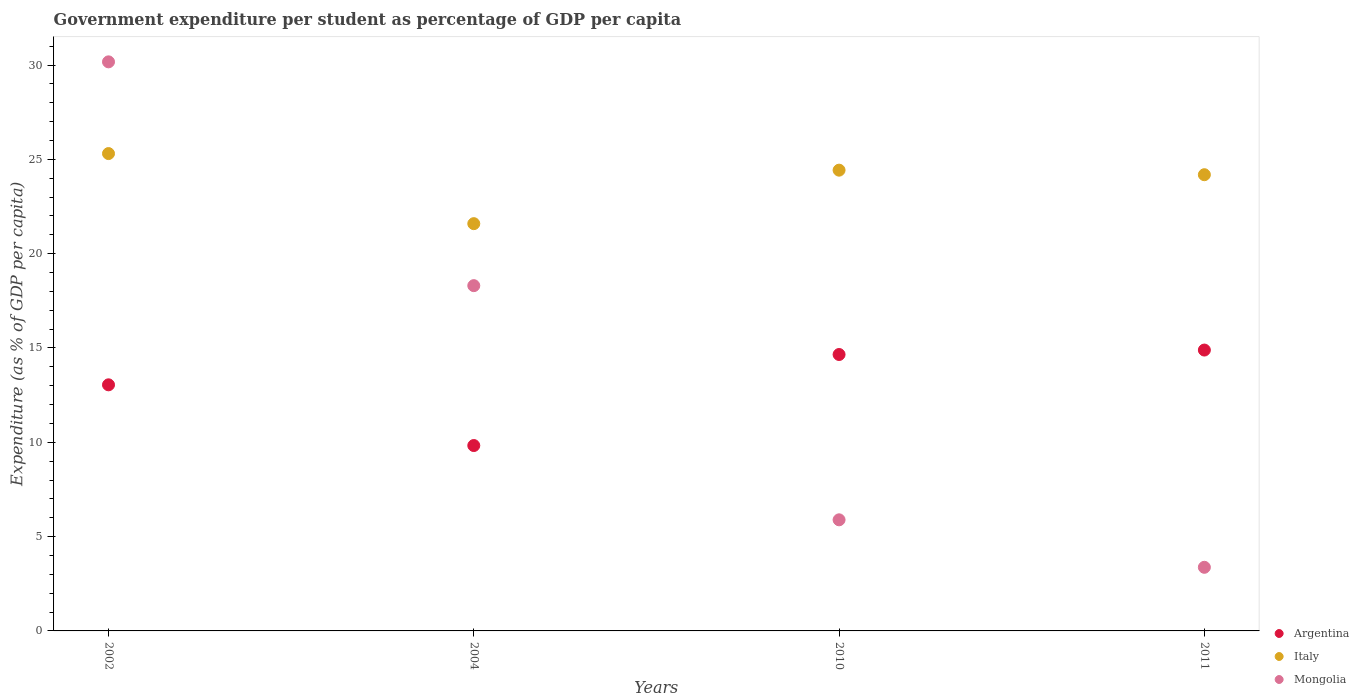How many different coloured dotlines are there?
Your answer should be compact. 3. Is the number of dotlines equal to the number of legend labels?
Make the answer very short. Yes. What is the percentage of expenditure per student in Mongolia in 2002?
Make the answer very short. 30.17. Across all years, what is the maximum percentage of expenditure per student in Argentina?
Offer a terse response. 14.89. Across all years, what is the minimum percentage of expenditure per student in Argentina?
Your answer should be compact. 9.83. In which year was the percentage of expenditure per student in Argentina maximum?
Provide a short and direct response. 2011. In which year was the percentage of expenditure per student in Argentina minimum?
Provide a short and direct response. 2004. What is the total percentage of expenditure per student in Italy in the graph?
Offer a very short reply. 95.51. What is the difference between the percentage of expenditure per student in Italy in 2002 and that in 2004?
Keep it short and to the point. 3.72. What is the difference between the percentage of expenditure per student in Italy in 2004 and the percentage of expenditure per student in Mongolia in 2010?
Your response must be concise. 15.7. What is the average percentage of expenditure per student in Mongolia per year?
Give a very brief answer. 14.43. In the year 2002, what is the difference between the percentage of expenditure per student in Italy and percentage of expenditure per student in Argentina?
Provide a succinct answer. 12.26. What is the ratio of the percentage of expenditure per student in Italy in 2004 to that in 2010?
Give a very brief answer. 0.88. Is the percentage of expenditure per student in Italy in 2010 less than that in 2011?
Your response must be concise. No. What is the difference between the highest and the second highest percentage of expenditure per student in Argentina?
Make the answer very short. 0.24. What is the difference between the highest and the lowest percentage of expenditure per student in Mongolia?
Ensure brevity in your answer.  26.8. In how many years, is the percentage of expenditure per student in Argentina greater than the average percentage of expenditure per student in Argentina taken over all years?
Make the answer very short. 2. Is the sum of the percentage of expenditure per student in Argentina in 2004 and 2011 greater than the maximum percentage of expenditure per student in Mongolia across all years?
Keep it short and to the point. No. Is it the case that in every year, the sum of the percentage of expenditure per student in Argentina and percentage of expenditure per student in Italy  is greater than the percentage of expenditure per student in Mongolia?
Provide a succinct answer. Yes. Is the percentage of expenditure per student in Mongolia strictly greater than the percentage of expenditure per student in Italy over the years?
Make the answer very short. No. Is the percentage of expenditure per student in Mongolia strictly less than the percentage of expenditure per student in Argentina over the years?
Ensure brevity in your answer.  No. How many dotlines are there?
Keep it short and to the point. 3. Does the graph contain any zero values?
Offer a terse response. No. Does the graph contain grids?
Make the answer very short. No. Where does the legend appear in the graph?
Give a very brief answer. Bottom right. How are the legend labels stacked?
Your answer should be compact. Vertical. What is the title of the graph?
Ensure brevity in your answer.  Government expenditure per student as percentage of GDP per capita. What is the label or title of the X-axis?
Ensure brevity in your answer.  Years. What is the label or title of the Y-axis?
Your answer should be very brief. Expenditure (as % of GDP per capita). What is the Expenditure (as % of GDP per capita) in Argentina in 2002?
Your response must be concise. 13.05. What is the Expenditure (as % of GDP per capita) in Italy in 2002?
Offer a very short reply. 25.31. What is the Expenditure (as % of GDP per capita) in Mongolia in 2002?
Your answer should be very brief. 30.17. What is the Expenditure (as % of GDP per capita) in Argentina in 2004?
Ensure brevity in your answer.  9.83. What is the Expenditure (as % of GDP per capita) in Italy in 2004?
Provide a succinct answer. 21.59. What is the Expenditure (as % of GDP per capita) of Mongolia in 2004?
Keep it short and to the point. 18.3. What is the Expenditure (as % of GDP per capita) of Argentina in 2010?
Offer a very short reply. 14.65. What is the Expenditure (as % of GDP per capita) in Italy in 2010?
Offer a very short reply. 24.43. What is the Expenditure (as % of GDP per capita) in Mongolia in 2010?
Provide a succinct answer. 5.89. What is the Expenditure (as % of GDP per capita) in Argentina in 2011?
Offer a very short reply. 14.89. What is the Expenditure (as % of GDP per capita) of Italy in 2011?
Give a very brief answer. 24.19. What is the Expenditure (as % of GDP per capita) in Mongolia in 2011?
Your answer should be compact. 3.37. Across all years, what is the maximum Expenditure (as % of GDP per capita) in Argentina?
Your answer should be compact. 14.89. Across all years, what is the maximum Expenditure (as % of GDP per capita) in Italy?
Provide a succinct answer. 25.31. Across all years, what is the maximum Expenditure (as % of GDP per capita) in Mongolia?
Ensure brevity in your answer.  30.17. Across all years, what is the minimum Expenditure (as % of GDP per capita) of Argentina?
Your answer should be very brief. 9.83. Across all years, what is the minimum Expenditure (as % of GDP per capita) of Italy?
Your response must be concise. 21.59. Across all years, what is the minimum Expenditure (as % of GDP per capita) of Mongolia?
Your answer should be very brief. 3.37. What is the total Expenditure (as % of GDP per capita) in Argentina in the graph?
Make the answer very short. 52.42. What is the total Expenditure (as % of GDP per capita) of Italy in the graph?
Your response must be concise. 95.51. What is the total Expenditure (as % of GDP per capita) of Mongolia in the graph?
Your answer should be very brief. 57.74. What is the difference between the Expenditure (as % of GDP per capita) of Argentina in 2002 and that in 2004?
Give a very brief answer. 3.22. What is the difference between the Expenditure (as % of GDP per capita) of Italy in 2002 and that in 2004?
Your response must be concise. 3.72. What is the difference between the Expenditure (as % of GDP per capita) of Mongolia in 2002 and that in 2004?
Your response must be concise. 11.86. What is the difference between the Expenditure (as % of GDP per capita) in Argentina in 2002 and that in 2010?
Keep it short and to the point. -1.61. What is the difference between the Expenditure (as % of GDP per capita) of Italy in 2002 and that in 2010?
Ensure brevity in your answer.  0.88. What is the difference between the Expenditure (as % of GDP per capita) in Mongolia in 2002 and that in 2010?
Ensure brevity in your answer.  24.28. What is the difference between the Expenditure (as % of GDP per capita) of Argentina in 2002 and that in 2011?
Ensure brevity in your answer.  -1.84. What is the difference between the Expenditure (as % of GDP per capita) of Italy in 2002 and that in 2011?
Your answer should be compact. 1.12. What is the difference between the Expenditure (as % of GDP per capita) in Mongolia in 2002 and that in 2011?
Offer a terse response. 26.8. What is the difference between the Expenditure (as % of GDP per capita) of Argentina in 2004 and that in 2010?
Provide a succinct answer. -4.83. What is the difference between the Expenditure (as % of GDP per capita) in Italy in 2004 and that in 2010?
Your answer should be very brief. -2.84. What is the difference between the Expenditure (as % of GDP per capita) in Mongolia in 2004 and that in 2010?
Keep it short and to the point. 12.41. What is the difference between the Expenditure (as % of GDP per capita) in Argentina in 2004 and that in 2011?
Your response must be concise. -5.06. What is the difference between the Expenditure (as % of GDP per capita) of Italy in 2004 and that in 2011?
Offer a terse response. -2.59. What is the difference between the Expenditure (as % of GDP per capita) in Mongolia in 2004 and that in 2011?
Make the answer very short. 14.93. What is the difference between the Expenditure (as % of GDP per capita) of Argentina in 2010 and that in 2011?
Provide a short and direct response. -0.24. What is the difference between the Expenditure (as % of GDP per capita) in Italy in 2010 and that in 2011?
Ensure brevity in your answer.  0.24. What is the difference between the Expenditure (as % of GDP per capita) of Mongolia in 2010 and that in 2011?
Provide a succinct answer. 2.52. What is the difference between the Expenditure (as % of GDP per capita) of Argentina in 2002 and the Expenditure (as % of GDP per capita) of Italy in 2004?
Ensure brevity in your answer.  -8.54. What is the difference between the Expenditure (as % of GDP per capita) in Argentina in 2002 and the Expenditure (as % of GDP per capita) in Mongolia in 2004?
Keep it short and to the point. -5.26. What is the difference between the Expenditure (as % of GDP per capita) in Italy in 2002 and the Expenditure (as % of GDP per capita) in Mongolia in 2004?
Give a very brief answer. 7. What is the difference between the Expenditure (as % of GDP per capita) in Argentina in 2002 and the Expenditure (as % of GDP per capita) in Italy in 2010?
Keep it short and to the point. -11.38. What is the difference between the Expenditure (as % of GDP per capita) in Argentina in 2002 and the Expenditure (as % of GDP per capita) in Mongolia in 2010?
Keep it short and to the point. 7.16. What is the difference between the Expenditure (as % of GDP per capita) in Italy in 2002 and the Expenditure (as % of GDP per capita) in Mongolia in 2010?
Your response must be concise. 19.42. What is the difference between the Expenditure (as % of GDP per capita) of Argentina in 2002 and the Expenditure (as % of GDP per capita) of Italy in 2011?
Your response must be concise. -11.14. What is the difference between the Expenditure (as % of GDP per capita) of Argentina in 2002 and the Expenditure (as % of GDP per capita) of Mongolia in 2011?
Your response must be concise. 9.67. What is the difference between the Expenditure (as % of GDP per capita) of Italy in 2002 and the Expenditure (as % of GDP per capita) of Mongolia in 2011?
Provide a succinct answer. 21.93. What is the difference between the Expenditure (as % of GDP per capita) of Argentina in 2004 and the Expenditure (as % of GDP per capita) of Italy in 2010?
Your answer should be compact. -14.6. What is the difference between the Expenditure (as % of GDP per capita) of Argentina in 2004 and the Expenditure (as % of GDP per capita) of Mongolia in 2010?
Provide a short and direct response. 3.94. What is the difference between the Expenditure (as % of GDP per capita) in Italy in 2004 and the Expenditure (as % of GDP per capita) in Mongolia in 2010?
Make the answer very short. 15.7. What is the difference between the Expenditure (as % of GDP per capita) in Argentina in 2004 and the Expenditure (as % of GDP per capita) in Italy in 2011?
Ensure brevity in your answer.  -14.36. What is the difference between the Expenditure (as % of GDP per capita) of Argentina in 2004 and the Expenditure (as % of GDP per capita) of Mongolia in 2011?
Keep it short and to the point. 6.46. What is the difference between the Expenditure (as % of GDP per capita) of Italy in 2004 and the Expenditure (as % of GDP per capita) of Mongolia in 2011?
Your answer should be compact. 18.22. What is the difference between the Expenditure (as % of GDP per capita) in Argentina in 2010 and the Expenditure (as % of GDP per capita) in Italy in 2011?
Your response must be concise. -9.53. What is the difference between the Expenditure (as % of GDP per capita) of Argentina in 2010 and the Expenditure (as % of GDP per capita) of Mongolia in 2011?
Ensure brevity in your answer.  11.28. What is the difference between the Expenditure (as % of GDP per capita) in Italy in 2010 and the Expenditure (as % of GDP per capita) in Mongolia in 2011?
Offer a very short reply. 21.05. What is the average Expenditure (as % of GDP per capita) of Argentina per year?
Your answer should be very brief. 13.1. What is the average Expenditure (as % of GDP per capita) in Italy per year?
Keep it short and to the point. 23.88. What is the average Expenditure (as % of GDP per capita) in Mongolia per year?
Offer a terse response. 14.43. In the year 2002, what is the difference between the Expenditure (as % of GDP per capita) of Argentina and Expenditure (as % of GDP per capita) of Italy?
Your response must be concise. -12.26. In the year 2002, what is the difference between the Expenditure (as % of GDP per capita) in Argentina and Expenditure (as % of GDP per capita) in Mongolia?
Ensure brevity in your answer.  -17.12. In the year 2002, what is the difference between the Expenditure (as % of GDP per capita) in Italy and Expenditure (as % of GDP per capita) in Mongolia?
Offer a very short reply. -4.86. In the year 2004, what is the difference between the Expenditure (as % of GDP per capita) in Argentina and Expenditure (as % of GDP per capita) in Italy?
Keep it short and to the point. -11.76. In the year 2004, what is the difference between the Expenditure (as % of GDP per capita) of Argentina and Expenditure (as % of GDP per capita) of Mongolia?
Ensure brevity in your answer.  -8.48. In the year 2004, what is the difference between the Expenditure (as % of GDP per capita) in Italy and Expenditure (as % of GDP per capita) in Mongolia?
Make the answer very short. 3.29. In the year 2010, what is the difference between the Expenditure (as % of GDP per capita) in Argentina and Expenditure (as % of GDP per capita) in Italy?
Your answer should be very brief. -9.77. In the year 2010, what is the difference between the Expenditure (as % of GDP per capita) in Argentina and Expenditure (as % of GDP per capita) in Mongolia?
Make the answer very short. 8.76. In the year 2010, what is the difference between the Expenditure (as % of GDP per capita) in Italy and Expenditure (as % of GDP per capita) in Mongolia?
Make the answer very short. 18.54. In the year 2011, what is the difference between the Expenditure (as % of GDP per capita) of Argentina and Expenditure (as % of GDP per capita) of Italy?
Provide a succinct answer. -9.3. In the year 2011, what is the difference between the Expenditure (as % of GDP per capita) of Argentina and Expenditure (as % of GDP per capita) of Mongolia?
Your answer should be very brief. 11.52. In the year 2011, what is the difference between the Expenditure (as % of GDP per capita) of Italy and Expenditure (as % of GDP per capita) of Mongolia?
Provide a short and direct response. 20.81. What is the ratio of the Expenditure (as % of GDP per capita) of Argentina in 2002 to that in 2004?
Offer a very short reply. 1.33. What is the ratio of the Expenditure (as % of GDP per capita) in Italy in 2002 to that in 2004?
Ensure brevity in your answer.  1.17. What is the ratio of the Expenditure (as % of GDP per capita) of Mongolia in 2002 to that in 2004?
Keep it short and to the point. 1.65. What is the ratio of the Expenditure (as % of GDP per capita) in Argentina in 2002 to that in 2010?
Keep it short and to the point. 0.89. What is the ratio of the Expenditure (as % of GDP per capita) of Italy in 2002 to that in 2010?
Provide a succinct answer. 1.04. What is the ratio of the Expenditure (as % of GDP per capita) in Mongolia in 2002 to that in 2010?
Give a very brief answer. 5.12. What is the ratio of the Expenditure (as % of GDP per capita) of Argentina in 2002 to that in 2011?
Give a very brief answer. 0.88. What is the ratio of the Expenditure (as % of GDP per capita) in Italy in 2002 to that in 2011?
Give a very brief answer. 1.05. What is the ratio of the Expenditure (as % of GDP per capita) of Mongolia in 2002 to that in 2011?
Your answer should be compact. 8.94. What is the ratio of the Expenditure (as % of GDP per capita) of Argentina in 2004 to that in 2010?
Make the answer very short. 0.67. What is the ratio of the Expenditure (as % of GDP per capita) in Italy in 2004 to that in 2010?
Your response must be concise. 0.88. What is the ratio of the Expenditure (as % of GDP per capita) of Mongolia in 2004 to that in 2010?
Your answer should be very brief. 3.11. What is the ratio of the Expenditure (as % of GDP per capita) in Argentina in 2004 to that in 2011?
Give a very brief answer. 0.66. What is the ratio of the Expenditure (as % of GDP per capita) of Italy in 2004 to that in 2011?
Provide a short and direct response. 0.89. What is the ratio of the Expenditure (as % of GDP per capita) in Mongolia in 2004 to that in 2011?
Give a very brief answer. 5.43. What is the ratio of the Expenditure (as % of GDP per capita) of Argentina in 2010 to that in 2011?
Offer a very short reply. 0.98. What is the ratio of the Expenditure (as % of GDP per capita) in Italy in 2010 to that in 2011?
Offer a very short reply. 1.01. What is the ratio of the Expenditure (as % of GDP per capita) of Mongolia in 2010 to that in 2011?
Offer a terse response. 1.75. What is the difference between the highest and the second highest Expenditure (as % of GDP per capita) of Argentina?
Ensure brevity in your answer.  0.24. What is the difference between the highest and the second highest Expenditure (as % of GDP per capita) of Italy?
Give a very brief answer. 0.88. What is the difference between the highest and the second highest Expenditure (as % of GDP per capita) of Mongolia?
Keep it short and to the point. 11.86. What is the difference between the highest and the lowest Expenditure (as % of GDP per capita) in Argentina?
Give a very brief answer. 5.06. What is the difference between the highest and the lowest Expenditure (as % of GDP per capita) of Italy?
Provide a short and direct response. 3.72. What is the difference between the highest and the lowest Expenditure (as % of GDP per capita) of Mongolia?
Your answer should be very brief. 26.8. 